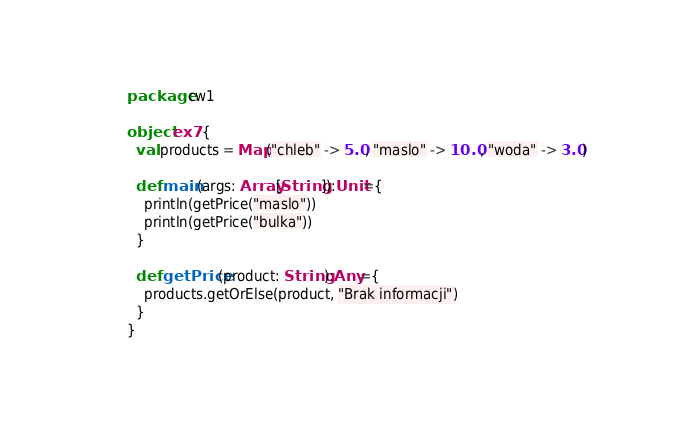<code> <loc_0><loc_0><loc_500><loc_500><_Scala_>package cw1

object ex7 {
  val products = Map("chleb" -> 5.0, "maslo" -> 10.0, "woda" -> 3.0)

  def main(args: Array[String]):Unit={
    println(getPrice("maslo"))
    println(getPrice("bulka"))
  }

  def getPrice(product: String):Any={
    products.getOrElse(product, "Brak informacji")
  }
}
</code> 